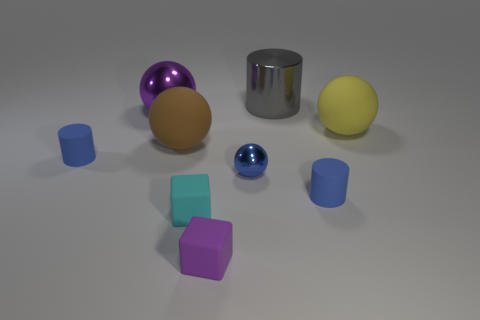There is a small thing that is the same color as the big shiny ball; what is its material?
Offer a terse response. Rubber. Is there a thing of the same color as the tiny shiny ball?
Ensure brevity in your answer.  Yes. The other rubber thing that is the same shape as the cyan rubber thing is what color?
Give a very brief answer. Purple. What number of objects are yellow metallic cubes or matte things that are to the left of the large brown sphere?
Offer a very short reply. 1. Are there fewer tiny metallic balls that are right of the large yellow rubber thing than small blue metal blocks?
Your answer should be very brief. No. What size is the blue rubber thing that is on the left side of the tiny blue rubber cylinder that is in front of the matte cylinder that is left of the small metal object?
Provide a succinct answer. Small. What color is the small rubber thing that is both on the right side of the cyan matte object and behind the small cyan block?
Keep it short and to the point. Blue. What number of big cyan objects are there?
Give a very brief answer. 0. Is the material of the blue sphere the same as the purple block?
Keep it short and to the point. No. Do the blue matte cylinder left of the cyan object and the blue rubber cylinder that is right of the large gray thing have the same size?
Keep it short and to the point. Yes. 